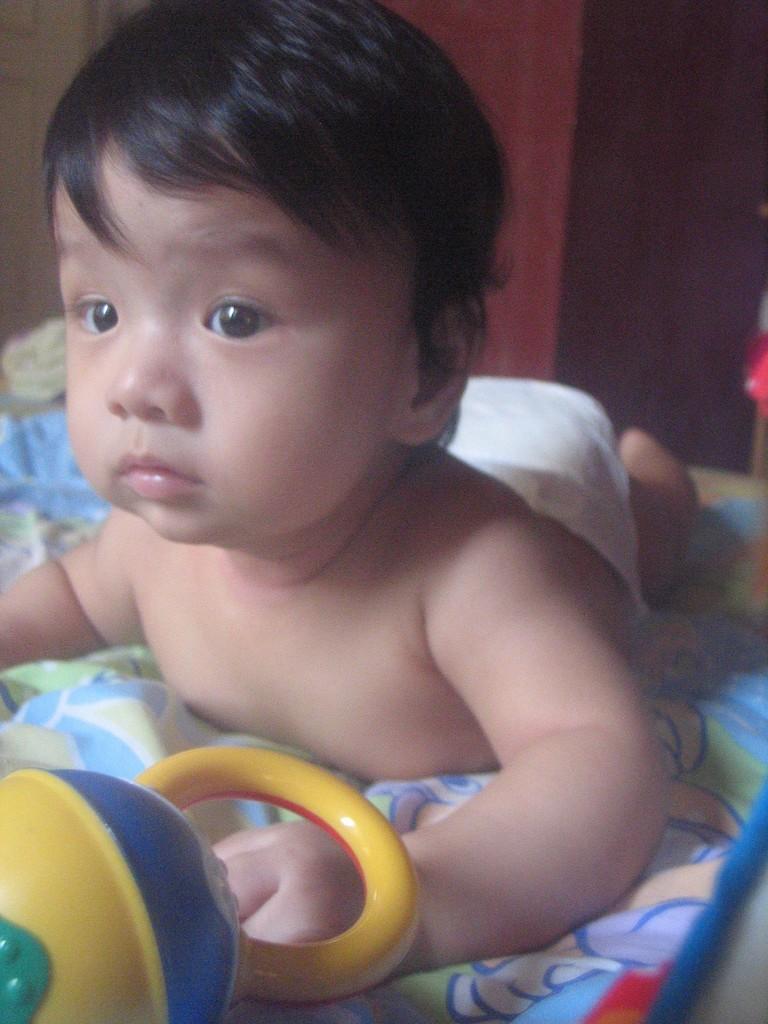Could you give a brief overview of what you see in this image? Background portion of the picture is blurred. In this picture we can see a kid is lying on a blanket. We can see a toy. 